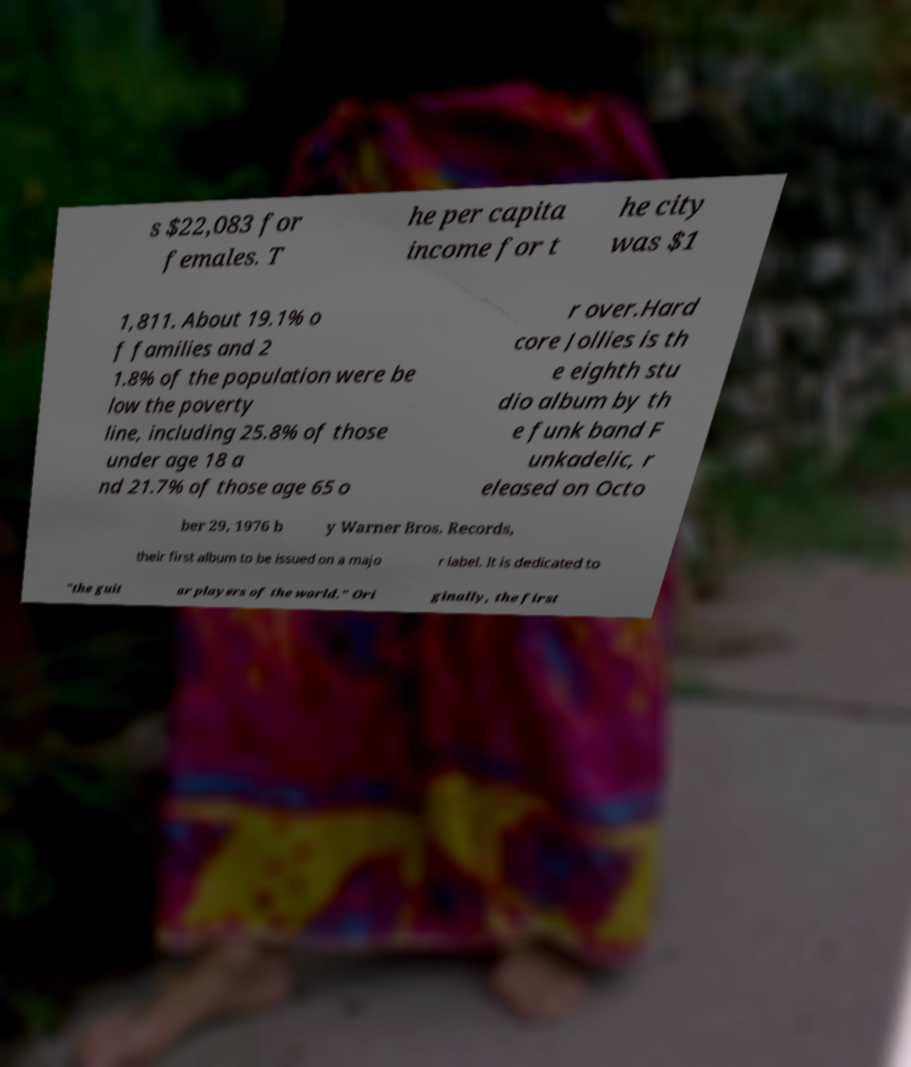Please read and relay the text visible in this image. What does it say? s $22,083 for females. T he per capita income for t he city was $1 1,811. About 19.1% o f families and 2 1.8% of the population were be low the poverty line, including 25.8% of those under age 18 a nd 21.7% of those age 65 o r over.Hard core Jollies is th e eighth stu dio album by th e funk band F unkadelic, r eleased on Octo ber 29, 1976 b y Warner Bros. Records, their first album to be issued on a majo r label. It is dedicated to "the guit ar players of the world." Ori ginally, the first 